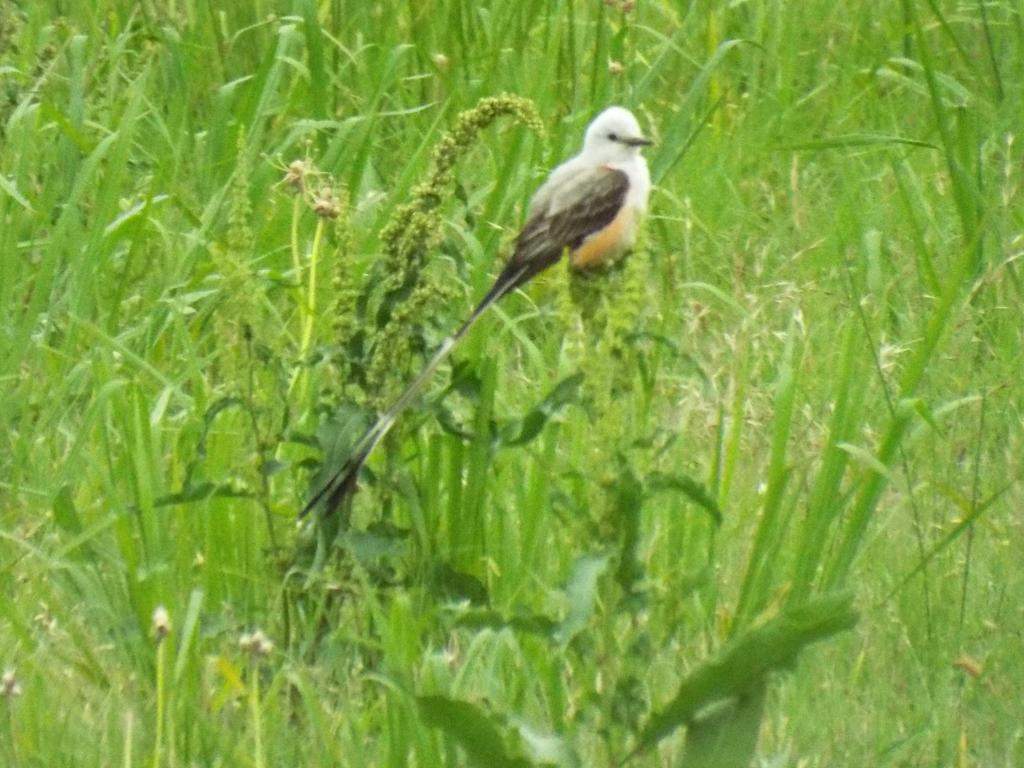What type of animal can be seen in the image? There is a bird in the image. What type of vegetation is present in the image? There is grass in the image. What advice does the bird's grandmother give in the image? There is no grandmother or advice present in the image; it features a bird and grass. What type of test is the bird taking in the image? There is no test or bird taking a test present in the image; it features a bird and grass. 